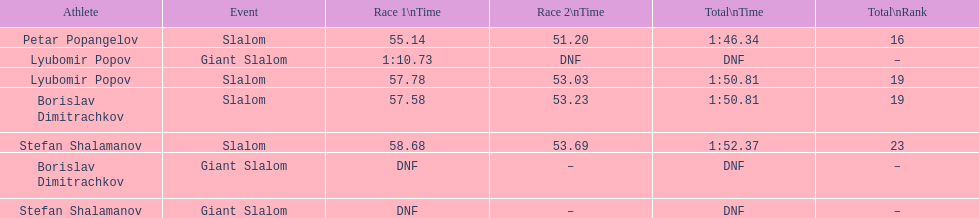Which athlete had a race time above 1:00? Lyubomir Popov. 